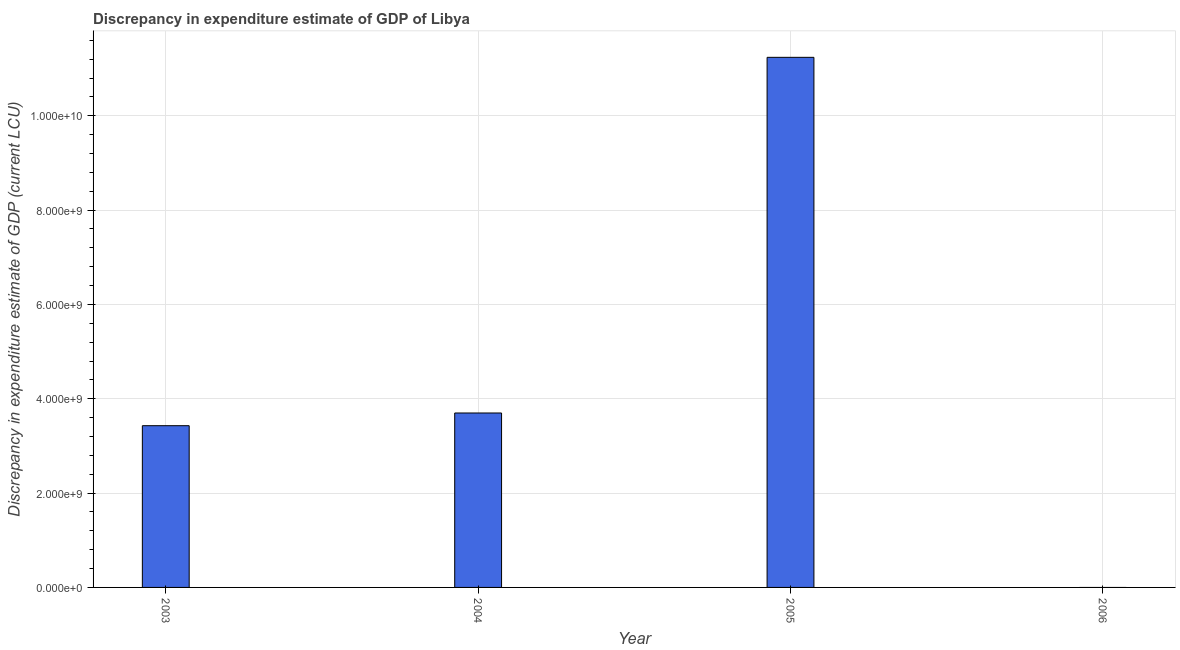What is the title of the graph?
Your answer should be very brief. Discrepancy in expenditure estimate of GDP of Libya. What is the label or title of the Y-axis?
Provide a short and direct response. Discrepancy in expenditure estimate of GDP (current LCU). What is the discrepancy in expenditure estimate of gdp in 2005?
Keep it short and to the point. 1.12e+1. Across all years, what is the maximum discrepancy in expenditure estimate of gdp?
Provide a succinct answer. 1.12e+1. In which year was the discrepancy in expenditure estimate of gdp maximum?
Your answer should be compact. 2005. What is the sum of the discrepancy in expenditure estimate of gdp?
Make the answer very short. 1.84e+1. What is the difference between the discrepancy in expenditure estimate of gdp in 2003 and 2004?
Offer a very short reply. -2.69e+08. What is the average discrepancy in expenditure estimate of gdp per year?
Make the answer very short. 4.59e+09. What is the median discrepancy in expenditure estimate of gdp?
Offer a very short reply. 3.56e+09. In how many years, is the discrepancy in expenditure estimate of gdp greater than 6000000000 LCU?
Offer a terse response. 1. What is the ratio of the discrepancy in expenditure estimate of gdp in 2004 to that in 2005?
Give a very brief answer. 0.33. Is the discrepancy in expenditure estimate of gdp in 2004 less than that in 2005?
Your response must be concise. Yes. Is the difference between the discrepancy in expenditure estimate of gdp in 2004 and 2005 greater than the difference between any two years?
Your answer should be very brief. No. What is the difference between the highest and the second highest discrepancy in expenditure estimate of gdp?
Provide a short and direct response. 7.54e+09. Is the sum of the discrepancy in expenditure estimate of gdp in 2003 and 2004 greater than the maximum discrepancy in expenditure estimate of gdp across all years?
Give a very brief answer. No. What is the difference between the highest and the lowest discrepancy in expenditure estimate of gdp?
Ensure brevity in your answer.  1.12e+1. How many bars are there?
Your answer should be compact. 3. Are all the bars in the graph horizontal?
Ensure brevity in your answer.  No. What is the difference between two consecutive major ticks on the Y-axis?
Give a very brief answer. 2.00e+09. What is the Discrepancy in expenditure estimate of GDP (current LCU) in 2003?
Keep it short and to the point. 3.43e+09. What is the Discrepancy in expenditure estimate of GDP (current LCU) in 2004?
Your answer should be very brief. 3.70e+09. What is the Discrepancy in expenditure estimate of GDP (current LCU) of 2005?
Offer a very short reply. 1.12e+1. What is the Discrepancy in expenditure estimate of GDP (current LCU) of 2006?
Offer a terse response. 0. What is the difference between the Discrepancy in expenditure estimate of GDP (current LCU) in 2003 and 2004?
Make the answer very short. -2.69e+08. What is the difference between the Discrepancy in expenditure estimate of GDP (current LCU) in 2003 and 2005?
Your response must be concise. -7.81e+09. What is the difference between the Discrepancy in expenditure estimate of GDP (current LCU) in 2004 and 2005?
Offer a terse response. -7.54e+09. What is the ratio of the Discrepancy in expenditure estimate of GDP (current LCU) in 2003 to that in 2004?
Make the answer very short. 0.93. What is the ratio of the Discrepancy in expenditure estimate of GDP (current LCU) in 2003 to that in 2005?
Offer a very short reply. 0.3. What is the ratio of the Discrepancy in expenditure estimate of GDP (current LCU) in 2004 to that in 2005?
Ensure brevity in your answer.  0.33. 